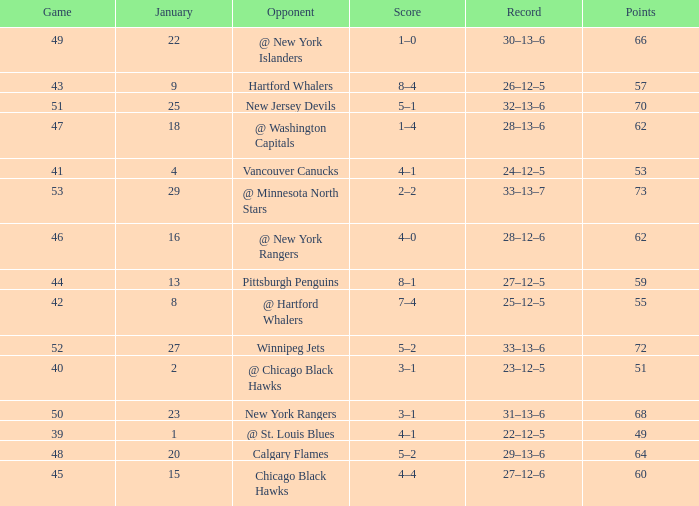Which January has a Score of 7–4, and a Game smaller than 42? None. 